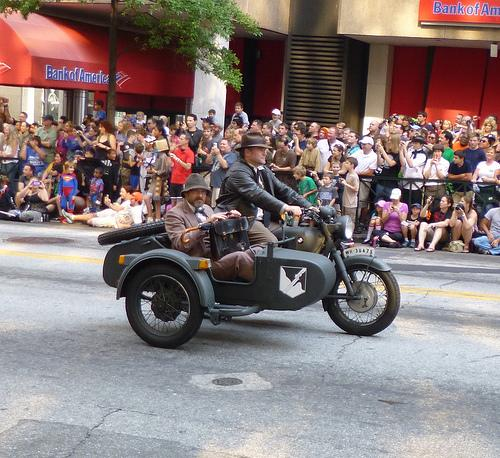Narrate the image from the perspective of a bystander in the scene. As I stood among the crowd, a fascinating sight caught our attention: a man driving a motorcycle, his companion riding in the sidecar. Mention the key elements in the image and their characteristics using a poetic language style. A beautiful old-style motorcycle, adorned with a sidecar, journeys along, while a vibrant assembly of curious souls stand by, enchanted. Provide a brief description of the primary object in the image and the action it is involved in. Two men are riding a motorcycle, with one man sitting in the sidecar and the other man driving it. Using informal language, describe a dominant subject and secondary subjects in the image. There's this guy driving a cool motorcycle with a sidecar, and a bunch of people just hanging out on the street watching. Using nostalgic language, provide a short commentary on the image. The bygone charm of a motorcycle and sidecar journeying down the street, attracting the wistful gazes of passersby. Summarize the content of the image in one sentence, mentioning the main objects and activities. Men riding a motorcycle with sidecar draw the attention of a diverse crowd of spectators on the street. Describe the atmosphere and setting of the image, highlighting the main action. An urban street scene unfolds as the exciting sight of a motorcycle with a sidecar captivates onlookers with anticipation. Pretend you are a news reporter and give a brief description of the scene in the image. In today's local event, a motorcycle with a sidecar generated excitement among onlookers, as the crowd gathered on the street to witness the spectacle. In a short sentence, describe a notable event taking place in the image. A group of people are waiting to watch an event, with some sitting on the ground and others holding cameras. Comment on the people's activities and attire in the image in a concise manner. People are observing, some wearing fedoras, a child in a Superman outfit, and a man in a leather jacket. 